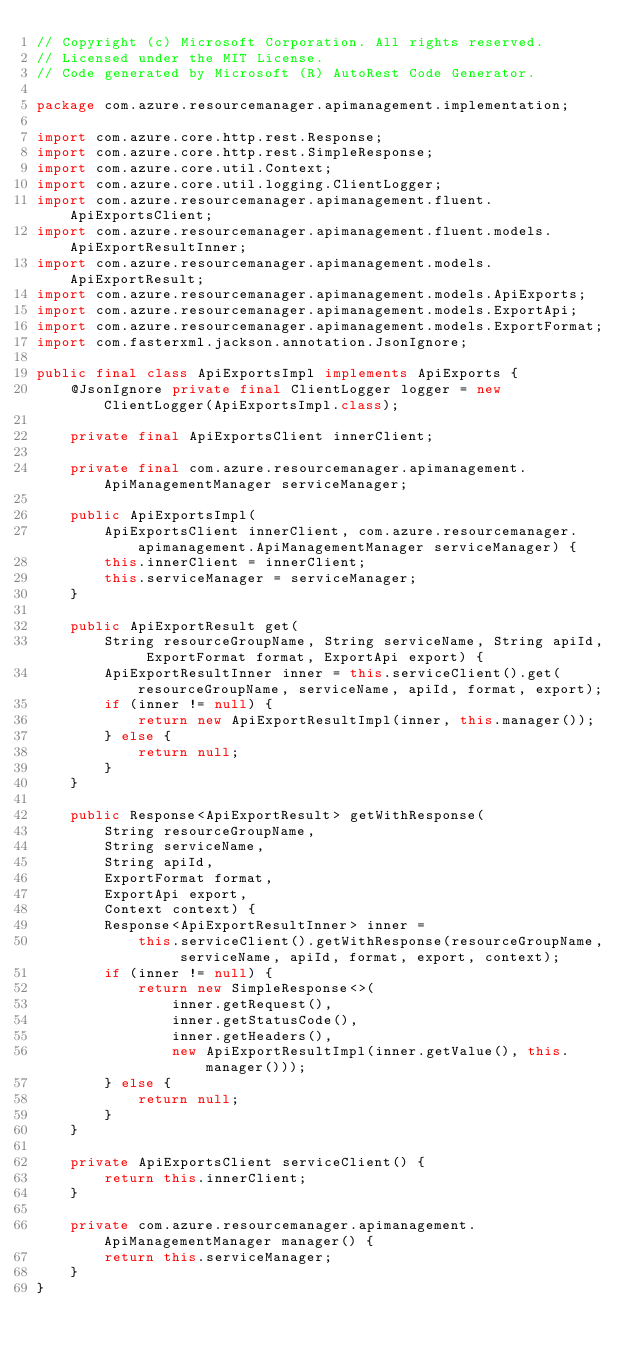<code> <loc_0><loc_0><loc_500><loc_500><_Java_>// Copyright (c) Microsoft Corporation. All rights reserved.
// Licensed under the MIT License.
// Code generated by Microsoft (R) AutoRest Code Generator.

package com.azure.resourcemanager.apimanagement.implementation;

import com.azure.core.http.rest.Response;
import com.azure.core.http.rest.SimpleResponse;
import com.azure.core.util.Context;
import com.azure.core.util.logging.ClientLogger;
import com.azure.resourcemanager.apimanagement.fluent.ApiExportsClient;
import com.azure.resourcemanager.apimanagement.fluent.models.ApiExportResultInner;
import com.azure.resourcemanager.apimanagement.models.ApiExportResult;
import com.azure.resourcemanager.apimanagement.models.ApiExports;
import com.azure.resourcemanager.apimanagement.models.ExportApi;
import com.azure.resourcemanager.apimanagement.models.ExportFormat;
import com.fasterxml.jackson.annotation.JsonIgnore;

public final class ApiExportsImpl implements ApiExports {
    @JsonIgnore private final ClientLogger logger = new ClientLogger(ApiExportsImpl.class);

    private final ApiExportsClient innerClient;

    private final com.azure.resourcemanager.apimanagement.ApiManagementManager serviceManager;

    public ApiExportsImpl(
        ApiExportsClient innerClient, com.azure.resourcemanager.apimanagement.ApiManagementManager serviceManager) {
        this.innerClient = innerClient;
        this.serviceManager = serviceManager;
    }

    public ApiExportResult get(
        String resourceGroupName, String serviceName, String apiId, ExportFormat format, ExportApi export) {
        ApiExportResultInner inner = this.serviceClient().get(resourceGroupName, serviceName, apiId, format, export);
        if (inner != null) {
            return new ApiExportResultImpl(inner, this.manager());
        } else {
            return null;
        }
    }

    public Response<ApiExportResult> getWithResponse(
        String resourceGroupName,
        String serviceName,
        String apiId,
        ExportFormat format,
        ExportApi export,
        Context context) {
        Response<ApiExportResultInner> inner =
            this.serviceClient().getWithResponse(resourceGroupName, serviceName, apiId, format, export, context);
        if (inner != null) {
            return new SimpleResponse<>(
                inner.getRequest(),
                inner.getStatusCode(),
                inner.getHeaders(),
                new ApiExportResultImpl(inner.getValue(), this.manager()));
        } else {
            return null;
        }
    }

    private ApiExportsClient serviceClient() {
        return this.innerClient;
    }

    private com.azure.resourcemanager.apimanagement.ApiManagementManager manager() {
        return this.serviceManager;
    }
}
</code> 